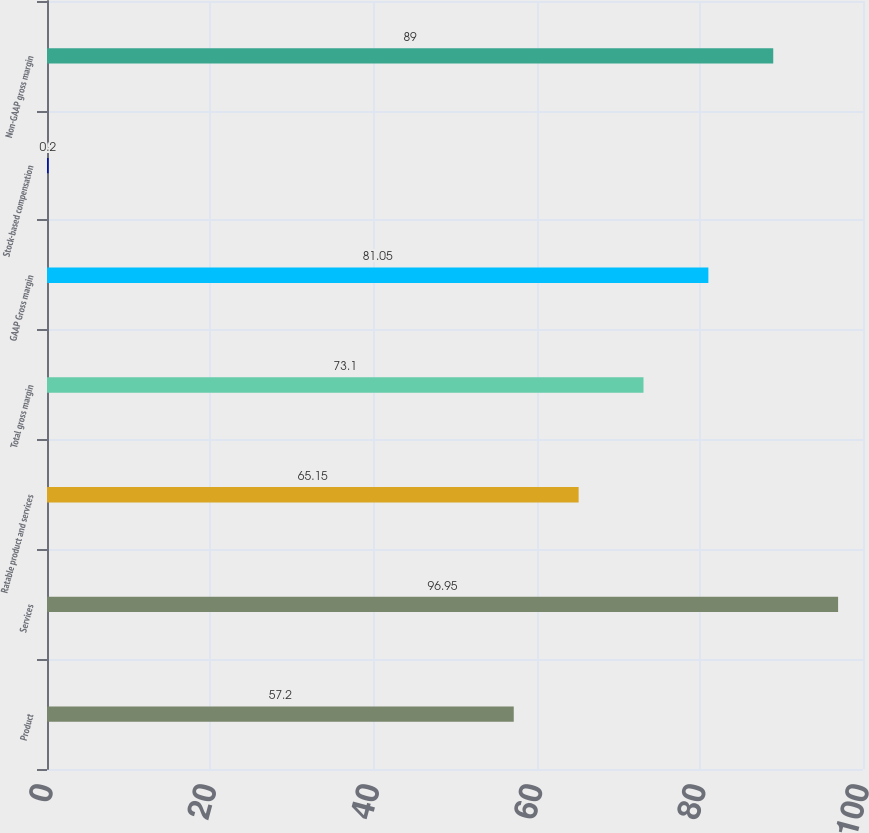Convert chart to OTSL. <chart><loc_0><loc_0><loc_500><loc_500><bar_chart><fcel>Product<fcel>Services<fcel>Ratable product and services<fcel>Total gross margin<fcel>GAAP Gross margin<fcel>Stock-based compensation<fcel>Non-GAAP gross margin<nl><fcel>57.2<fcel>96.95<fcel>65.15<fcel>73.1<fcel>81.05<fcel>0.2<fcel>89<nl></chart> 